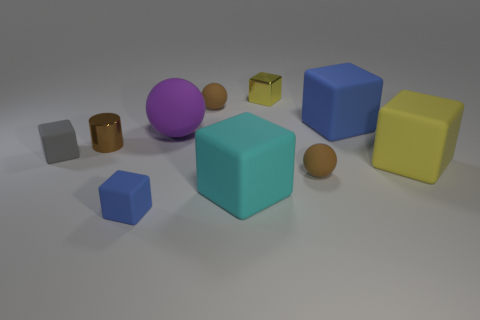Subtract all small blue blocks. How many blocks are left? 5 Subtract all yellow blocks. How many blocks are left? 4 Subtract all cyan blocks. Subtract all gray cylinders. How many blocks are left? 5 Subtract all spheres. How many objects are left? 7 Subtract 0 green balls. How many objects are left? 10 Subtract all large yellow things. Subtract all cyan cubes. How many objects are left? 8 Add 3 large cubes. How many large cubes are left? 6 Add 8 big cyan rubber blocks. How many big cyan rubber blocks exist? 9 